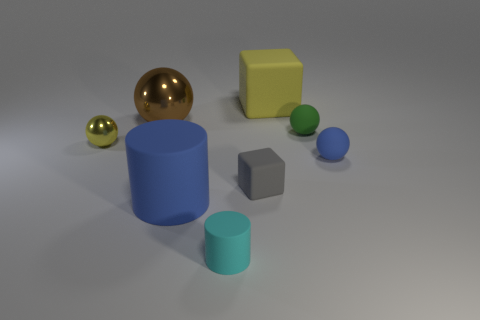Do the large matte block and the tiny metallic sphere have the same color?
Give a very brief answer. Yes. What is the color of the large cube that is made of the same material as the tiny cyan object?
Keep it short and to the point. Yellow. What number of cyan metal things are the same size as the yellow metallic sphere?
Offer a very short reply. 0. What is the small yellow ball made of?
Offer a very short reply. Metal. Are there more tiny gray objects than matte cubes?
Provide a short and direct response. No. Does the small gray matte object have the same shape as the yellow rubber object?
Your response must be concise. Yes. Is the color of the large rubber thing that is to the left of the cyan cylinder the same as the sphere in front of the small shiny ball?
Provide a short and direct response. Yes. Are there fewer tiny cylinders behind the blue matte cylinder than metallic objects that are left of the big metallic thing?
Keep it short and to the point. Yes. There is a big thing that is to the right of the small block; what shape is it?
Offer a terse response. Cube. There is a object that is the same color as the big rubber cylinder; what material is it?
Your response must be concise. Rubber. 